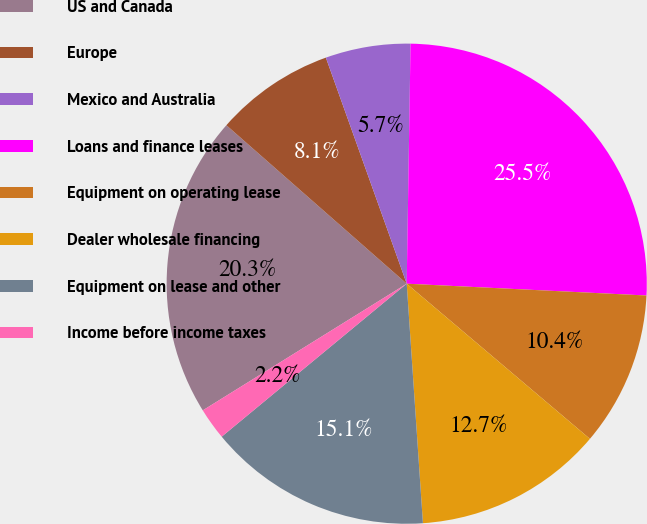Convert chart to OTSL. <chart><loc_0><loc_0><loc_500><loc_500><pie_chart><fcel>US and Canada<fcel>Europe<fcel>Mexico and Australia<fcel>Loans and finance leases<fcel>Equipment on operating lease<fcel>Dealer wholesale financing<fcel>Equipment on lease and other<fcel>Income before income taxes<nl><fcel>20.32%<fcel>8.06%<fcel>5.72%<fcel>25.53%<fcel>10.4%<fcel>12.74%<fcel>15.08%<fcel>2.15%<nl></chart> 